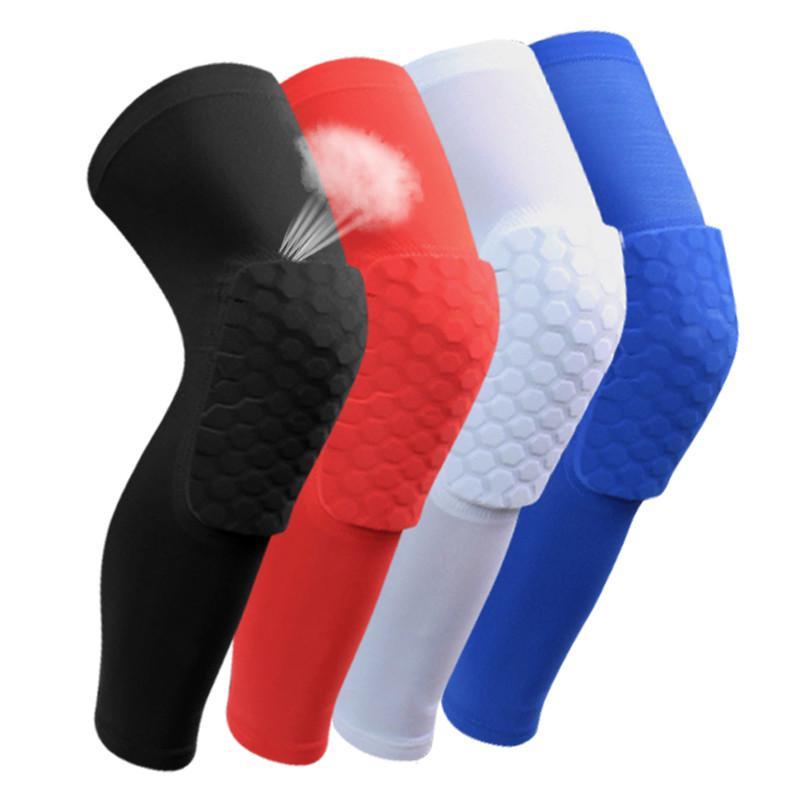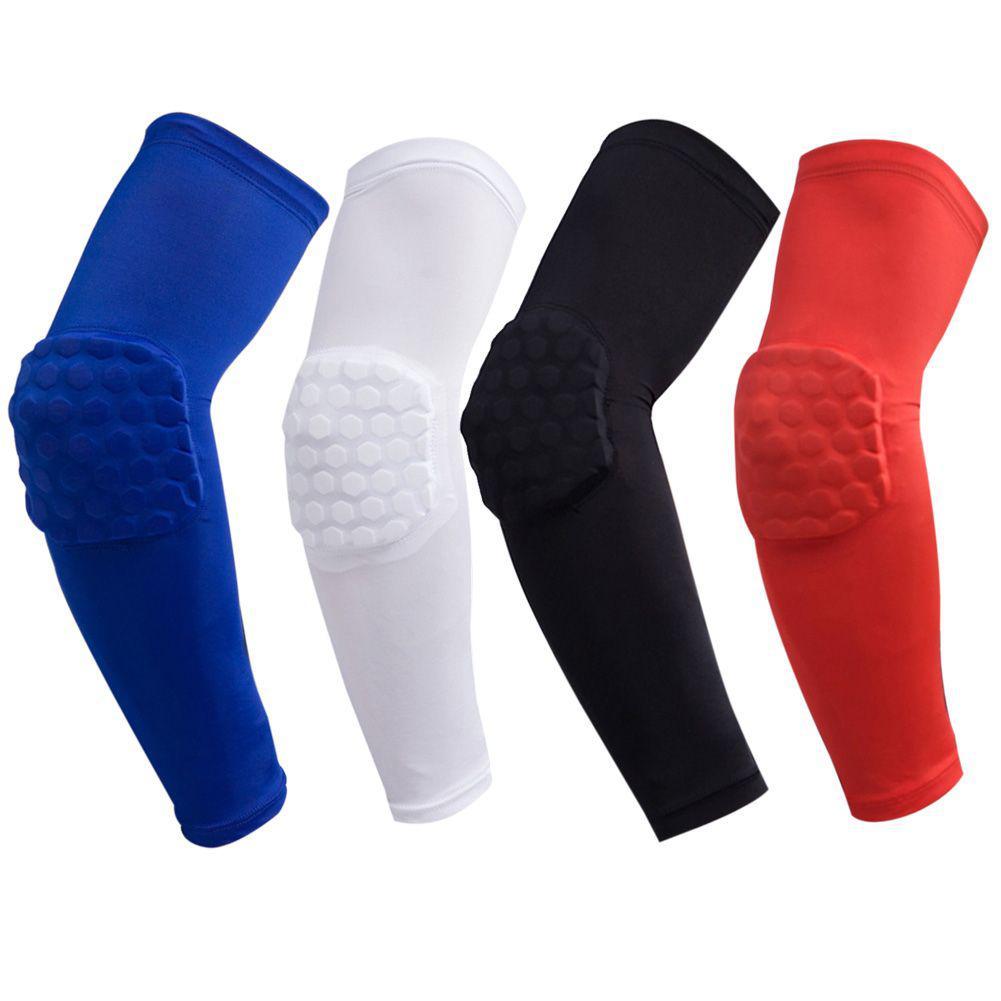The first image is the image on the left, the second image is the image on the right. Examine the images to the left and right. Is the description "Eight compression socks with knee pads are visible." accurate? Answer yes or no. Yes. The first image is the image on the left, the second image is the image on the right. Considering the images on both sides, is "The right image shows 4 knee guards facing to the right." valid? Answer yes or no. No. 